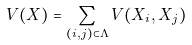<formula> <loc_0><loc_0><loc_500><loc_500>V ( X ) = \sum _ { ( i , j ) \subset \Lambda } V ( X _ { i } , X _ { j } )</formula> 